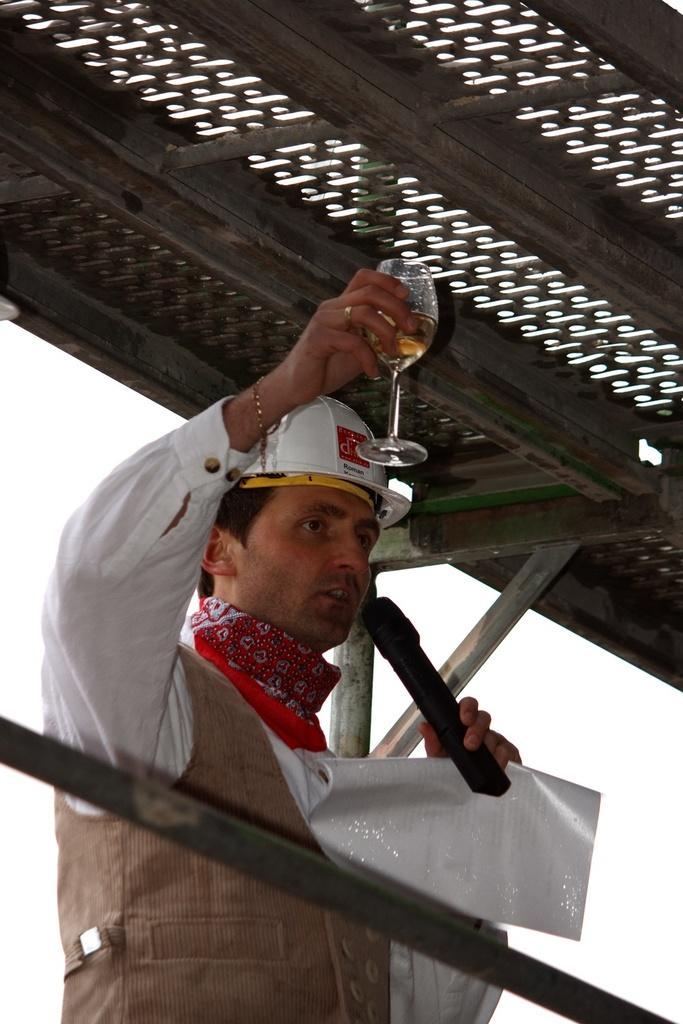Could you give a brief overview of what you see in this image? In this picture there is a man who is standing in the center of the image, by holding a glass, mic, and a paper in his hands and there is a roof at the top side of the image, it seems to be there is a railing at the bottom side of the image. 